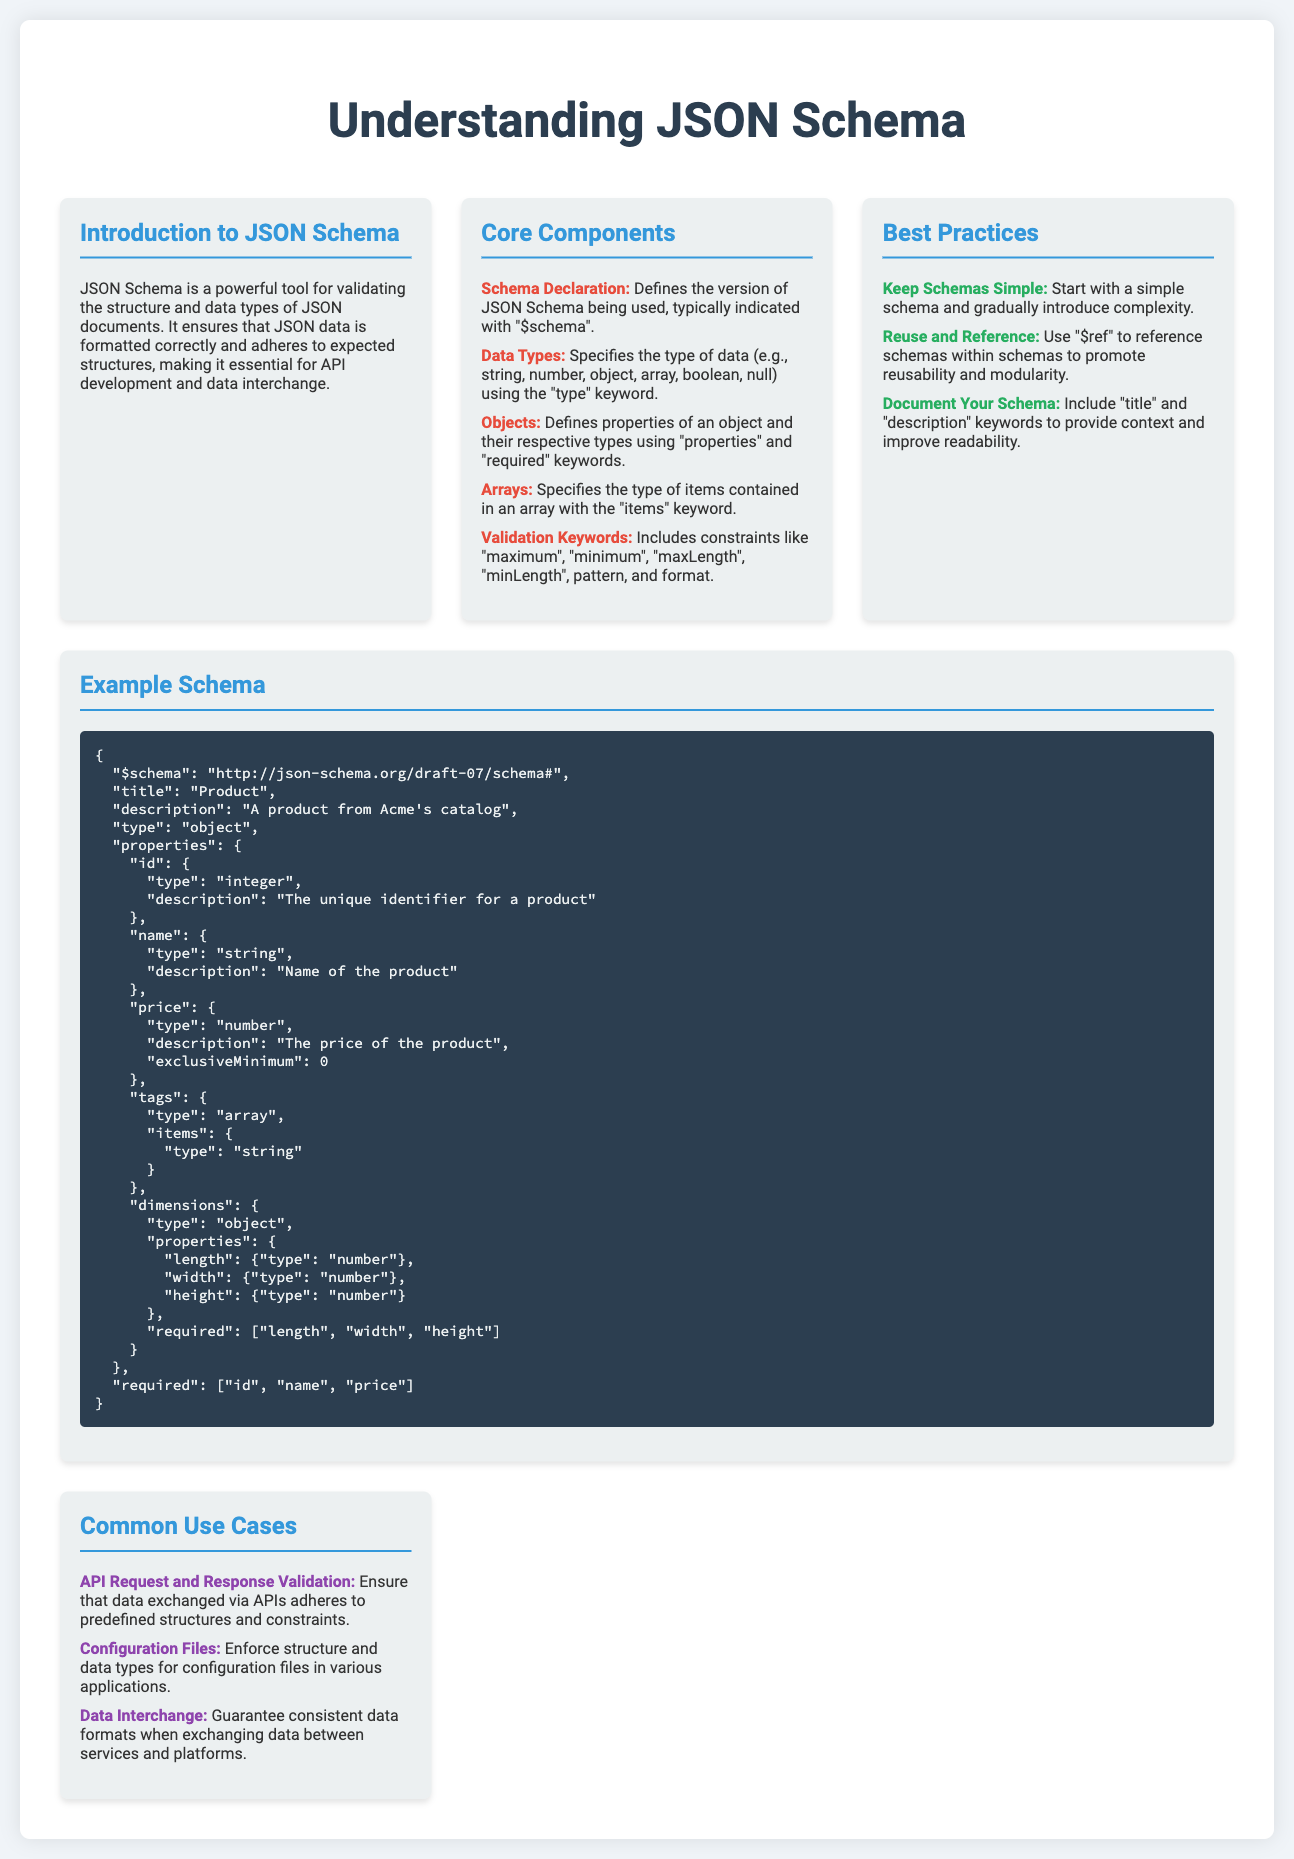What is the title of the poster? The title is prominently displayed at the top of the poster, which is "Understanding JSON Schema."
Answer: Understanding JSON Schema What data type is specified for the "id" property in the example schema? The example schema specifies the "id" as an "integer," which is explicitly mentioned in the properties section.
Answer: integer What is a key recommendation for schema design mentioned in the best practices? The best practices highlight that schemas should be simple initially and gradually gain complexity.
Answer: Keep Schemas Simple What is the purpose of JSON Schema according to the introduction? The introduction outlines that JSON Schema is used to validate the structure and data types of JSON documents, which is essential for various applications.
Answer: Validate structure and data types What is the required property that specifies the unique identifier for a product? The example schema indicates that the "id" property is required to uniquely identify a product.
Answer: id What is the function of the "$ref" keyword in best practices? The "$ref" keyword is mentioned as a way to reference schemas within other schemas, aiding in reusability and modularity.
Answer: Reuse and Reference What number corresponds to the draft version stated in the example schema? The example schema shows the draft version is "07," indicating the version of JSON Schema being used.
Answer: 07 